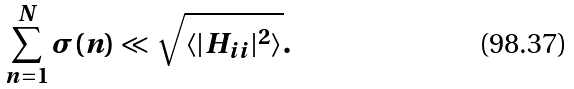<formula> <loc_0><loc_0><loc_500><loc_500>\sum _ { n = 1 } ^ { N } \sigma ( n ) \ll \sqrt { \langle | H _ { i i } | ^ { 2 } \rangle } .</formula> 